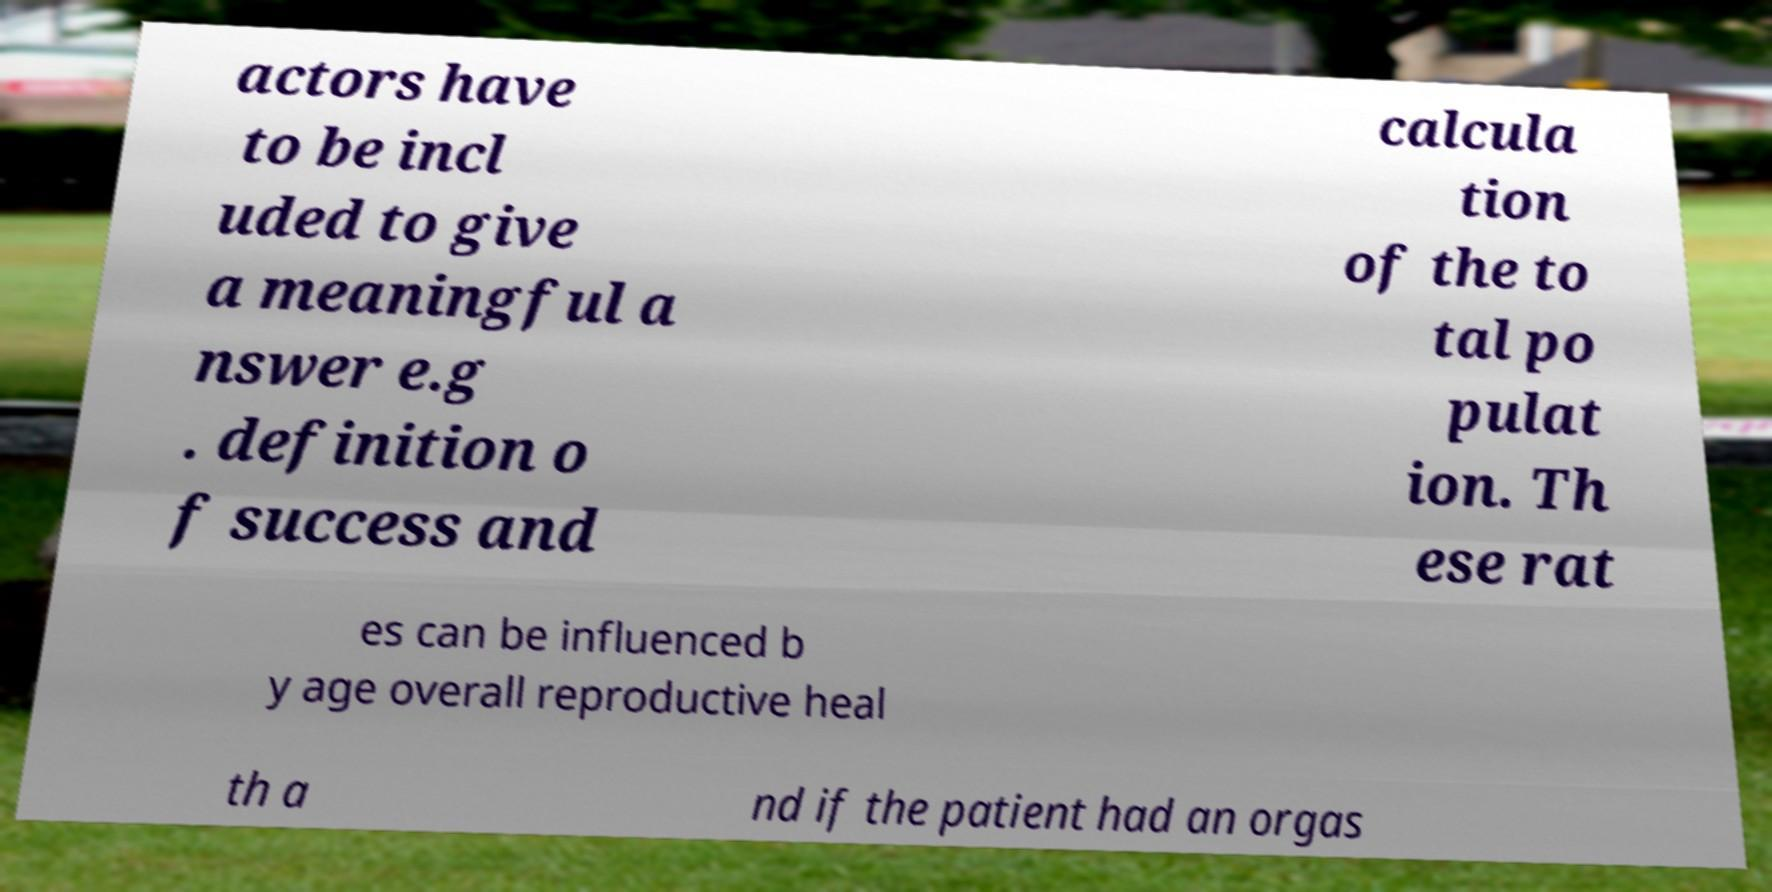Can you read and provide the text displayed in the image?This photo seems to have some interesting text. Can you extract and type it out for me? actors have to be incl uded to give a meaningful a nswer e.g . definition o f success and calcula tion of the to tal po pulat ion. Th ese rat es can be influenced b y age overall reproductive heal th a nd if the patient had an orgas 